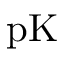<formula> <loc_0><loc_0><loc_500><loc_500>p K</formula> 